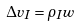Convert formula to latex. <formula><loc_0><loc_0><loc_500><loc_500>\Delta v _ { I } = \rho _ { I } w</formula> 